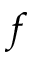<formula> <loc_0><loc_0><loc_500><loc_500>f</formula> 